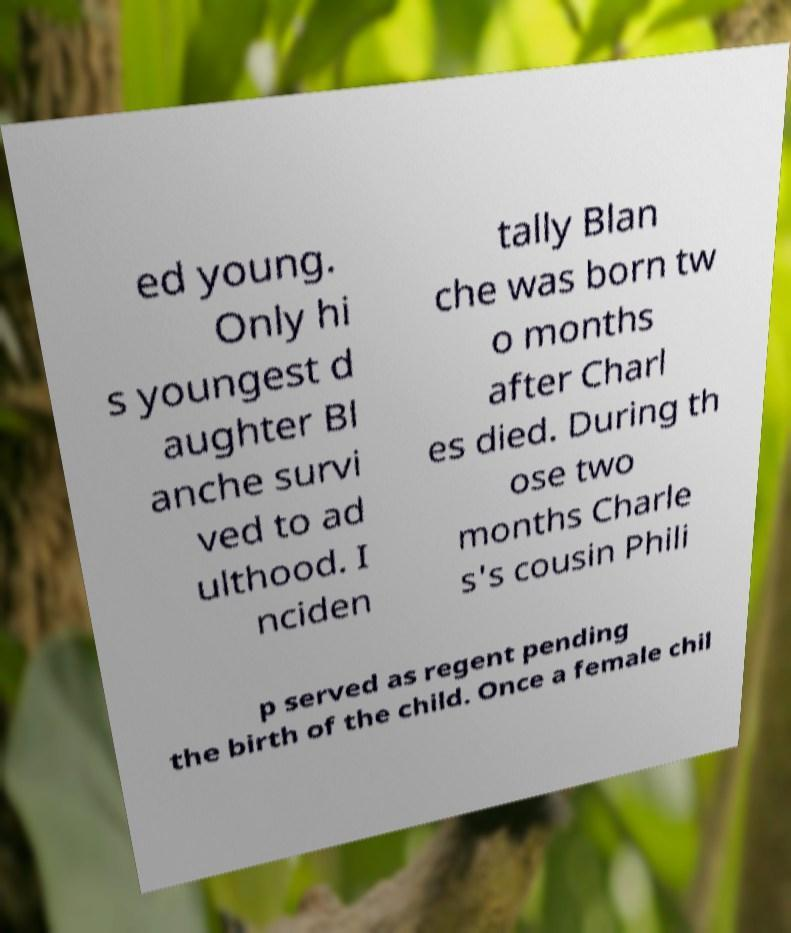I need the written content from this picture converted into text. Can you do that? ed young. Only hi s youngest d aughter Bl anche survi ved to ad ulthood. I nciden tally Blan che was born tw o months after Charl es died. During th ose two months Charle s's cousin Phili p served as regent pending the birth of the child. Once a female chil 